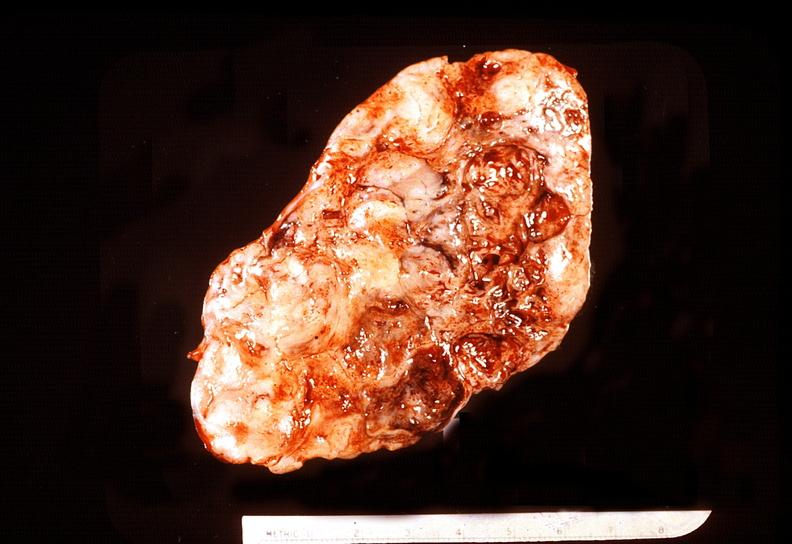where does this belong to?
Answer the question using a single word or phrase. Endocrine system 